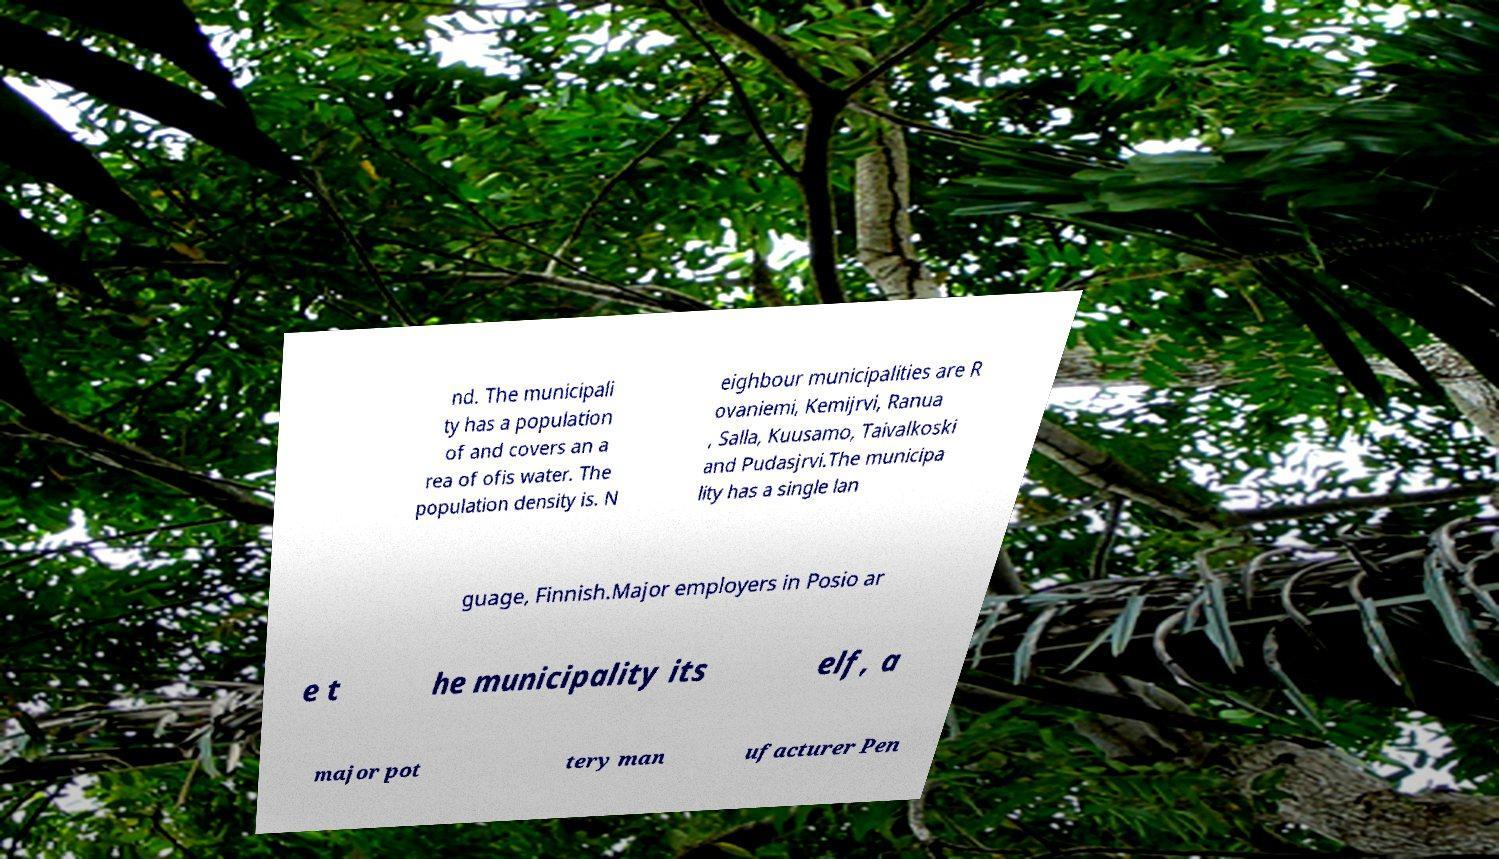For documentation purposes, I need the text within this image transcribed. Could you provide that? nd. The municipali ty has a population of and covers an a rea of ofis water. The population density is. N eighbour municipalities are R ovaniemi, Kemijrvi, Ranua , Salla, Kuusamo, Taivalkoski and Pudasjrvi.The municipa lity has a single lan guage, Finnish.Major employers in Posio ar e t he municipality its elf, a major pot tery man ufacturer Pen 